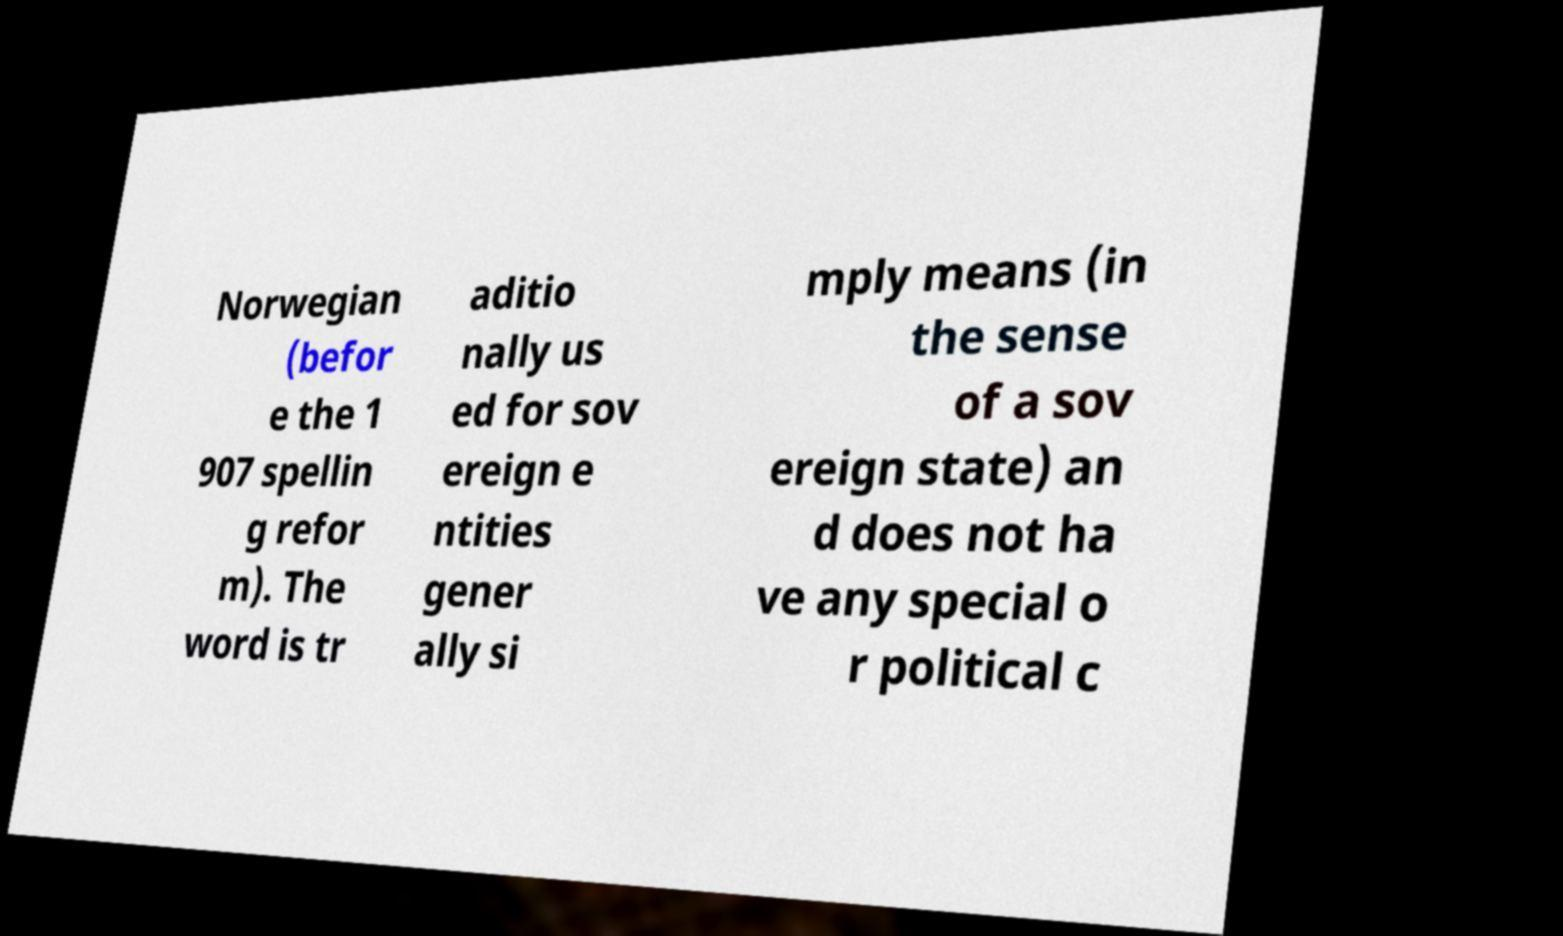Please read and relay the text visible in this image. What does it say? Norwegian (befor e the 1 907 spellin g refor m). The word is tr aditio nally us ed for sov ereign e ntities gener ally si mply means (in the sense of a sov ereign state) an d does not ha ve any special o r political c 